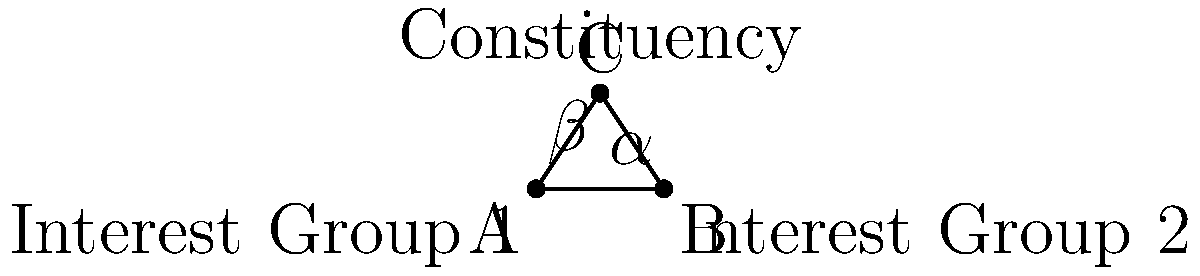In a constituency with two conflicting interest groups, their positions are represented by points A and B, while the overall constituency's interest is represented by point C. If the angle between the lines AC and BC is 60°, what is the measure of angle α, which represents the alignment of Interest Group 1 with the constituency's interest? To solve this problem, we'll use the properties of triangles and angles:

1. In triangle ABC, we know that the sum of all angles is 180°.
   $\alpha + \beta + 60° = 180°$

2. We can also observe that α and β are base angles of an isosceles triangle (since AC = BC, as they represent equal influence from the constituency point C).

3. Because the base angles of an isosceles triangle are equal:
   $\alpha = \beta$

4. Let's substitute this into our equation from step 1:
   $\alpha + \alpha + 60° = 180°$
   $2\alpha + 60° = 180°$

5. Solve for α:
   $2\alpha = 120°$
   $\alpha = 60°$

Therefore, the measure of angle α, representing the alignment of Interest Group 1 with the constituency's interest, is 60°.
Answer: 60° 